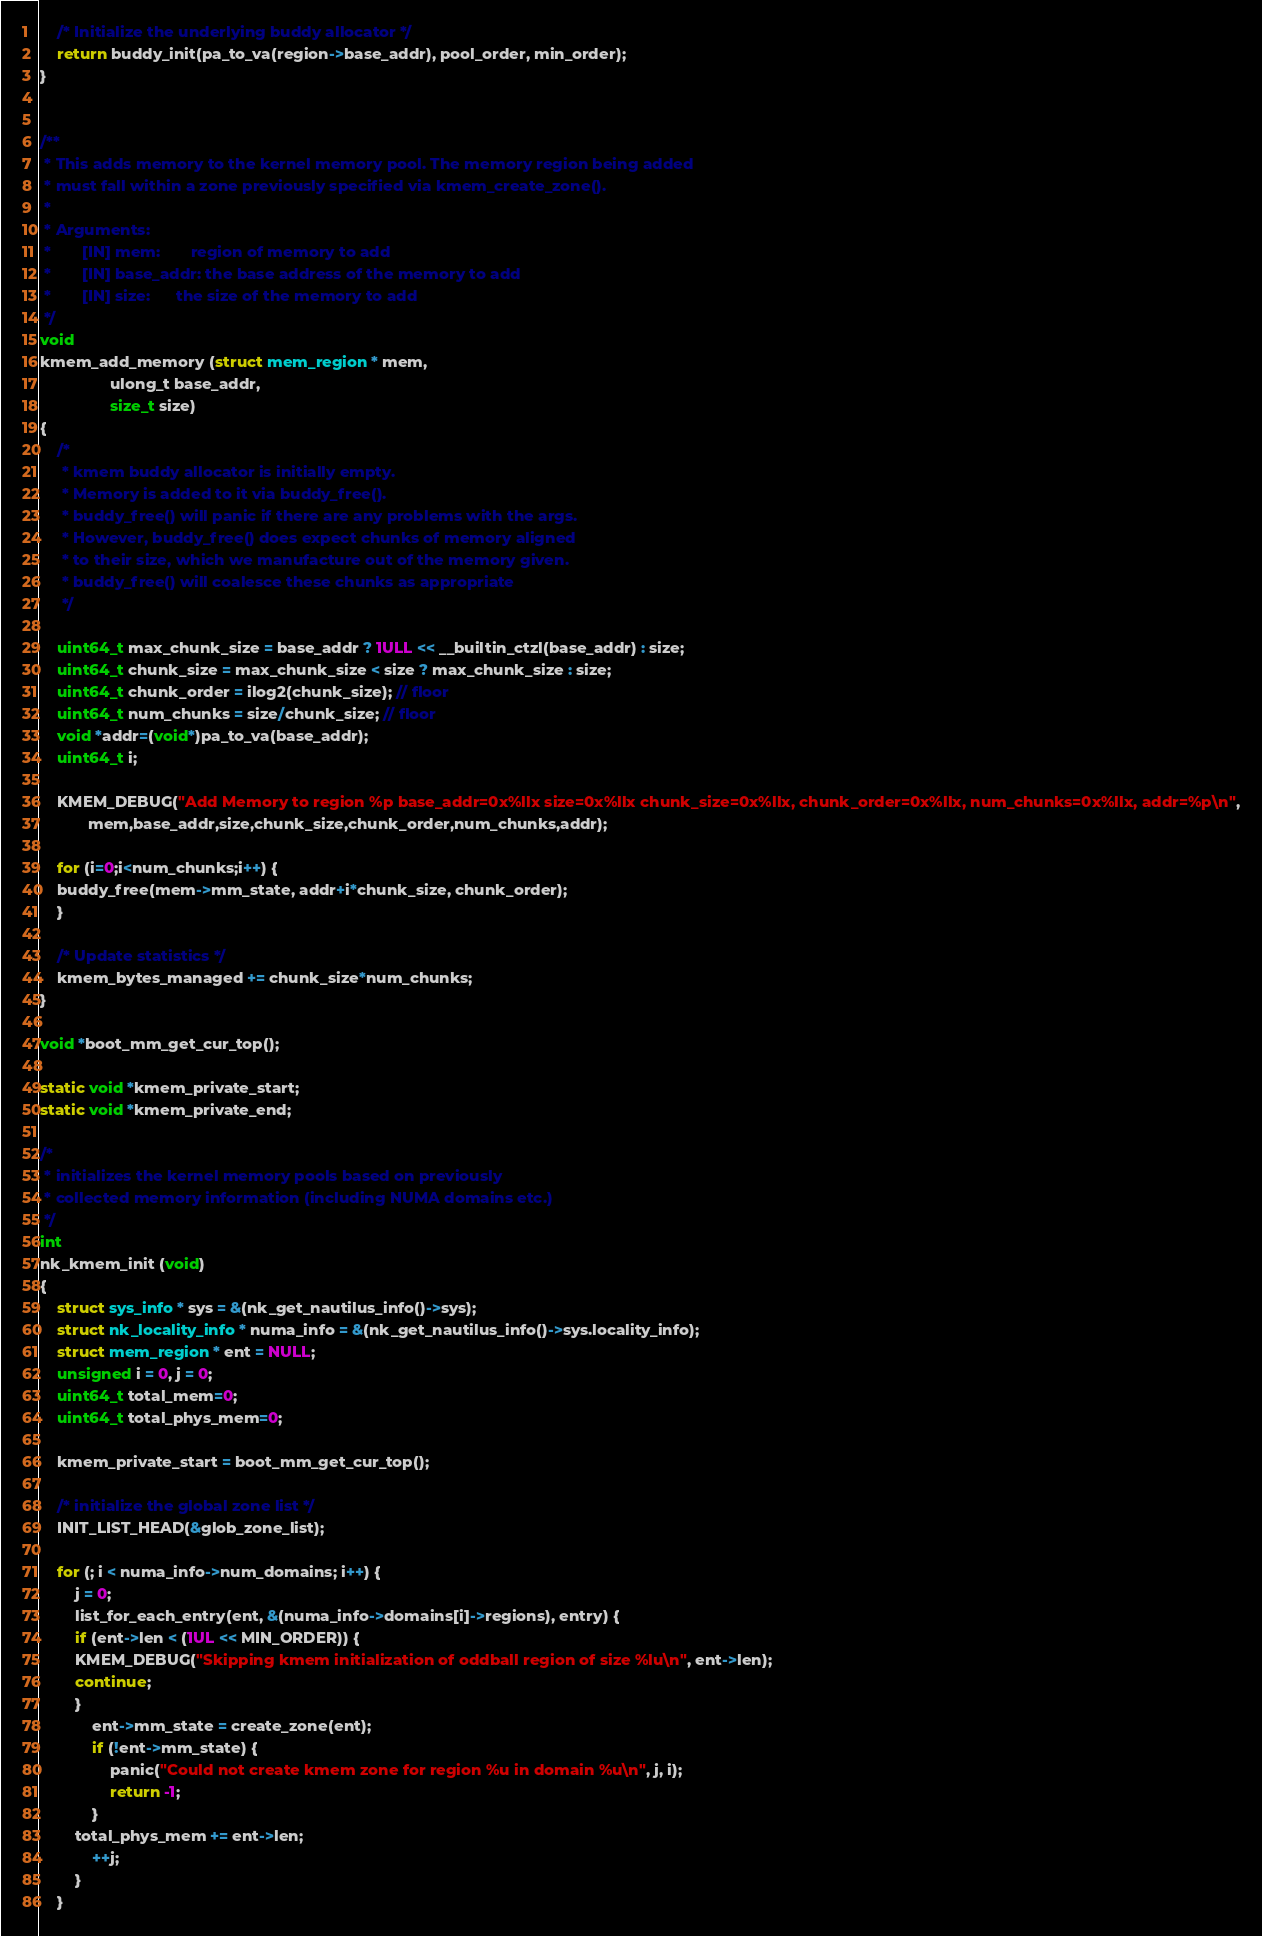<code> <loc_0><loc_0><loc_500><loc_500><_C_>
    /* Initialize the underlying buddy allocator */
    return buddy_init(pa_to_va(region->base_addr), pool_order, min_order);
}


/**
 * This adds memory to the kernel memory pool. The memory region being added
 * must fall within a zone previously specified via kmem_create_zone().
 *
 * Arguments:
 *       [IN] mem:       region of memory to add
 *       [IN] base_addr: the base address of the memory to add
 *       [IN] size:      the size of the memory to add
 */
void
kmem_add_memory (struct mem_region * mem, 
                ulong_t base_addr, 
                size_t size)
{
    /*
     * kmem buddy allocator is initially empty.
     * Memory is added to it via buddy_free().
     * buddy_free() will panic if there are any problems with the args.
     * However, buddy_free() does expect chunks of memory aligned
     * to their size, which we manufacture out of the memory given.
     * buddy_free() will coalesce these chunks as appropriate
     */

    uint64_t max_chunk_size = base_addr ? 1ULL << __builtin_ctzl(base_addr) : size;
    uint64_t chunk_size = max_chunk_size < size ? max_chunk_size : size;
    uint64_t chunk_order = ilog2(chunk_size); // floor
    uint64_t num_chunks = size/chunk_size; // floor
    void *addr=(void*)pa_to_va(base_addr);
    uint64_t i;

    KMEM_DEBUG("Add Memory to region %p base_addr=0x%llx size=0x%llx chunk_size=0x%llx, chunk_order=0x%llx, num_chunks=0x%llx, addr=%p\n",
	       mem,base_addr,size,chunk_size,chunk_order,num_chunks,addr);
    
    for (i=0;i<num_chunks;i++) { 
	buddy_free(mem->mm_state, addr+i*chunk_size, chunk_order);
    }

    /* Update statistics */
    kmem_bytes_managed += chunk_size*num_chunks;
}

void *boot_mm_get_cur_top();

static void *kmem_private_start;
static void *kmem_private_end;

/* 
 * initializes the kernel memory pools based on previously 
 * collected memory information (including NUMA domains etc.)
 */
int
nk_kmem_init (void)
{
    struct sys_info * sys = &(nk_get_nautilus_info()->sys);
    struct nk_locality_info * numa_info = &(nk_get_nautilus_info()->sys.locality_info);
    struct mem_region * ent = NULL;
    unsigned i = 0, j = 0;
    uint64_t total_mem=0;
    uint64_t total_phys_mem=0;
    
    kmem_private_start = boot_mm_get_cur_top();

    /* initialize the global zone list */
    INIT_LIST_HEAD(&glob_zone_list);

    for (; i < numa_info->num_domains; i++) {
        j = 0;
        list_for_each_entry(ent, &(numa_info->domains[i]->regions), entry) {
	    if (ent->len < (1UL << MIN_ORDER)) { 
		KMEM_DEBUG("Skipping kmem initialization of oddball region of size %lu\n", ent->len);
		continue;
	    }
            ent->mm_state = create_zone(ent);
            if (!ent->mm_state) {
                panic("Could not create kmem zone for region %u in domain %u\n", j, i);
                return -1;
            }
	    total_phys_mem += ent->len;
            ++j;
        }
    }
</code> 